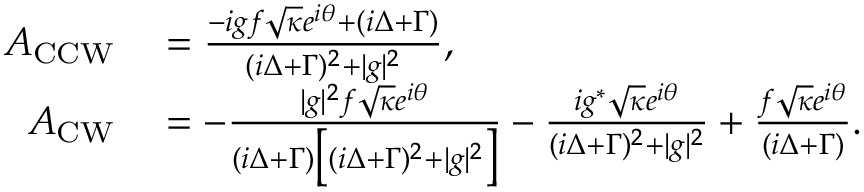Convert formula to latex. <formula><loc_0><loc_0><loc_500><loc_500>\begin{array} { r l } { A _ { C C W } } & = \frac { - i g f \sqrt { \kappa } e ^ { i \theta } + ( i \Delta + \Gamma ) } { ( i \Delta + \Gamma ) ^ { 2 } + | g | ^ { 2 } } , } \\ { A _ { C W } } & = - \frac { | g | ^ { 2 } f \sqrt { \kappa } e ^ { i \theta } } { ( i \Delta + \Gamma ) \left [ ( i \Delta + \Gamma ) ^ { 2 } + | g | ^ { 2 } \right ] } - \frac { i g ^ { * } \sqrt { \kappa } e ^ { i \theta } } { ( i \Delta + \Gamma ) ^ { 2 } + | g | ^ { 2 } } + \frac { f \sqrt { \kappa } e ^ { i \theta } } { ( i \Delta + \Gamma ) } . } \end{array}</formula> 